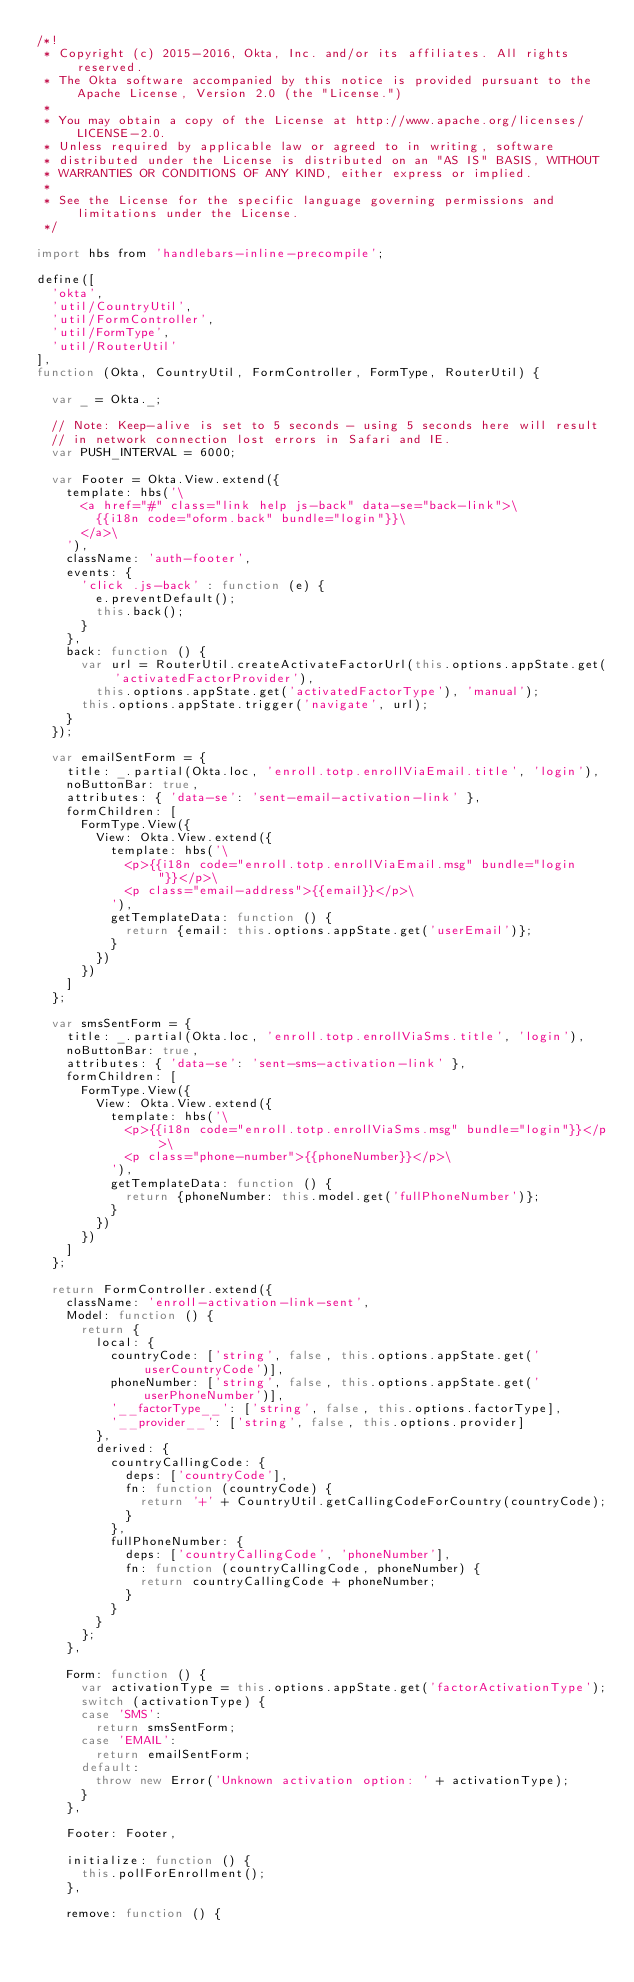<code> <loc_0><loc_0><loc_500><loc_500><_JavaScript_>/*!
 * Copyright (c) 2015-2016, Okta, Inc. and/or its affiliates. All rights reserved.
 * The Okta software accompanied by this notice is provided pursuant to the Apache License, Version 2.0 (the "License.")
 *
 * You may obtain a copy of the License at http://www.apache.org/licenses/LICENSE-2.0.
 * Unless required by applicable law or agreed to in writing, software
 * distributed under the License is distributed on an "AS IS" BASIS, WITHOUT
 * WARRANTIES OR CONDITIONS OF ANY KIND, either express or implied.
 *
 * See the License for the specific language governing permissions and limitations under the License.
 */

import hbs from 'handlebars-inline-precompile';

define([
  'okta',
  'util/CountryUtil',
  'util/FormController',
  'util/FormType',
  'util/RouterUtil'
],
function (Okta, CountryUtil, FormController, FormType, RouterUtil) {

  var _ = Okta._;

  // Note: Keep-alive is set to 5 seconds - using 5 seconds here will result
  // in network connection lost errors in Safari and IE.
  var PUSH_INTERVAL = 6000;

  var Footer = Okta.View.extend({
    template: hbs('\
      <a href="#" class="link help js-back" data-se="back-link">\
        {{i18n code="oform.back" bundle="login"}}\
      </a>\
    '),
    className: 'auth-footer',
    events: {
      'click .js-back' : function (e) {
        e.preventDefault();
        this.back();
      }
    },
    back: function () {
      var url = RouterUtil.createActivateFactorUrl(this.options.appState.get('activatedFactorProvider'),
        this.options.appState.get('activatedFactorType'), 'manual');
      this.options.appState.trigger('navigate', url);
    }
  });

  var emailSentForm = {
    title: _.partial(Okta.loc, 'enroll.totp.enrollViaEmail.title', 'login'),
    noButtonBar: true,
    attributes: { 'data-se': 'sent-email-activation-link' },
    formChildren: [
      FormType.View({
        View: Okta.View.extend({
          template: hbs('\
            <p>{{i18n code="enroll.totp.enrollViaEmail.msg" bundle="login"}}</p>\
            <p class="email-address">{{email}}</p>\
          '),
          getTemplateData: function () {
            return {email: this.options.appState.get('userEmail')};
          }
        })
      })
    ]
  };

  var smsSentForm = {
    title: _.partial(Okta.loc, 'enroll.totp.enrollViaSms.title', 'login'),
    noButtonBar: true,
    attributes: { 'data-se': 'sent-sms-activation-link' },
    formChildren: [
      FormType.View({
        View: Okta.View.extend({
          template: hbs('\
            <p>{{i18n code="enroll.totp.enrollViaSms.msg" bundle="login"}}</p>\
            <p class="phone-number">{{phoneNumber}}</p>\
          '),
          getTemplateData: function () {
            return {phoneNumber: this.model.get('fullPhoneNumber')};
          }
        })
      })
    ]
  };

  return FormController.extend({
    className: 'enroll-activation-link-sent',
    Model: function () {
      return {
        local: {
          countryCode: ['string', false, this.options.appState.get('userCountryCode')],
          phoneNumber: ['string', false, this.options.appState.get('userPhoneNumber')],
          '__factorType__': ['string', false, this.options.factorType],
          '__provider__': ['string', false, this.options.provider]
        },
        derived: {
          countryCallingCode: {
            deps: ['countryCode'],
            fn: function (countryCode) {
              return '+' + CountryUtil.getCallingCodeForCountry(countryCode);
            }
          },
          fullPhoneNumber: {
            deps: ['countryCallingCode', 'phoneNumber'],
            fn: function (countryCallingCode, phoneNumber) {
              return countryCallingCode + phoneNumber;
            }
          }
        }
      };
    },

    Form: function () {
      var activationType = this.options.appState.get('factorActivationType');
      switch (activationType) {
      case 'SMS':
        return smsSentForm;
      case 'EMAIL':
        return emailSentForm;
      default:
        throw new Error('Unknown activation option: ' + activationType);
      }
    },

    Footer: Footer,

    initialize: function () {
      this.pollForEnrollment();
    },

    remove: function () {</code> 